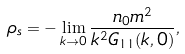Convert formula to latex. <formula><loc_0><loc_0><loc_500><loc_500>\rho _ { s } = - \lim _ { k \to 0 } \frac { n _ { 0 } m ^ { 2 } } { k ^ { 2 } G _ { 1 1 } ( k , 0 ) } ,</formula> 